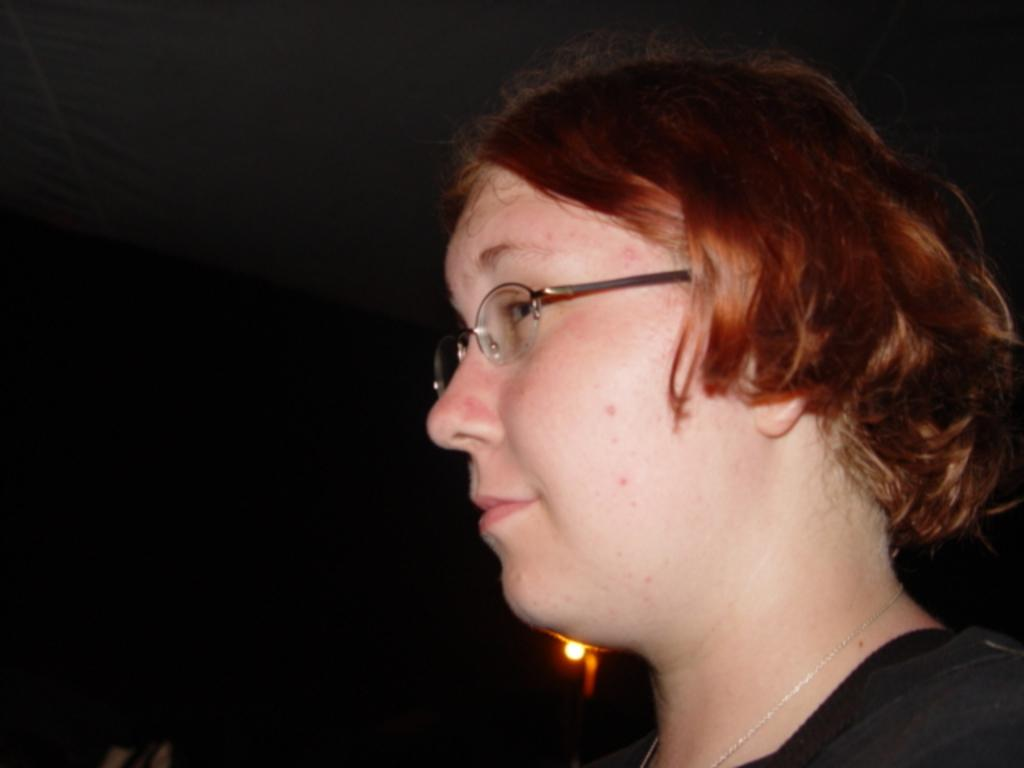Who is the main subject in the foreground of the image? There is a woman in the foreground of the image. On which side of the image is the woman located? The woman is on the right side of the image. What can be seen in the background of the image? There is a light in the background of the image. How would you describe the overall lighting in the image? The background is dark, which suggests that the lighting is dim or low. How many sheep are visible in the image? There are no sheep present in the image. What type of wall is featured in the image? There is no wall featured in the image. 